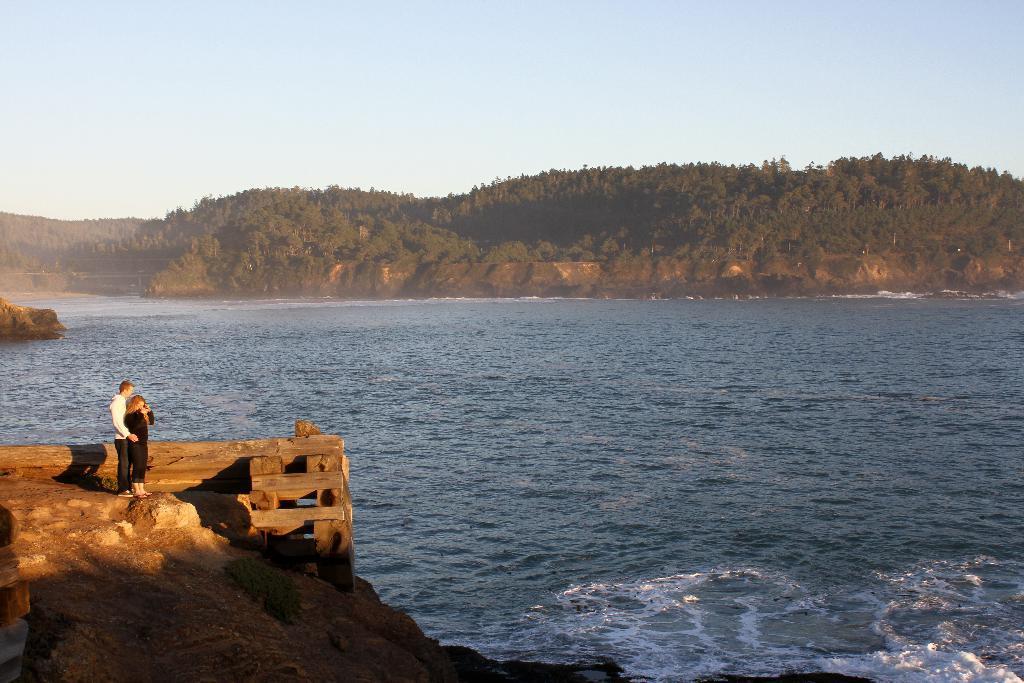Describe this image in one or two sentences. In this image I can see a couple standing on the rock, in-front of them there is some water and mountains. 